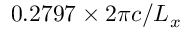Convert formula to latex. <formula><loc_0><loc_0><loc_500><loc_500>0 . 2 7 9 7 \times 2 \pi c / L _ { x }</formula> 